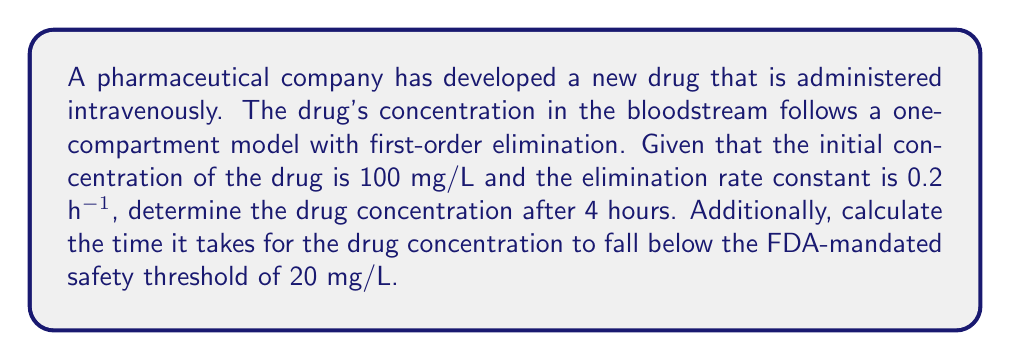Can you answer this question? Let's approach this problem step-by-step using ordinary differential equations:

1) In a one-compartment model with first-order elimination, the rate of change of drug concentration (C) with respect to time (t) is given by:

   $$\frac{dC}{dt} = -kC$$

   where k is the elimination rate constant.

2) The solution to this differential equation is:

   $$C(t) = C_0e^{-kt}$$

   where $C_0$ is the initial concentration.

3) Given:
   $C_0 = 100$ mg/L
   $k = 0.2$ h^(-1)

4) To find the concentration after 4 hours, we substitute t = 4 into the equation:

   $$C(4) = 100e^{-0.2(4)} = 100e^{-0.8} \approx 44.93$$ mg/L

5) To find when the concentration falls below 20 mg/L, we solve:

   $$20 = 100e^{-0.2t}$$

6) Taking natural logarithms of both sides:

   $$\ln(0.2) = -0.2t$$

7) Solving for t:

   $$t = \frac{-\ln(0.2)}{0.2} \approx 8.05$$ hours

Therefore, it takes approximately 8.05 hours for the drug concentration to fall below the FDA-mandated safety threshold of 20 mg/L.
Answer: 44.93 mg/L after 4 hours; 8.05 hours to reach 20 mg/L 